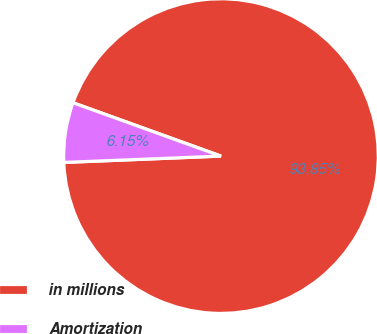Convert chart. <chart><loc_0><loc_0><loc_500><loc_500><pie_chart><fcel>in millions<fcel>Amortization<nl><fcel>93.85%<fcel>6.15%<nl></chart> 